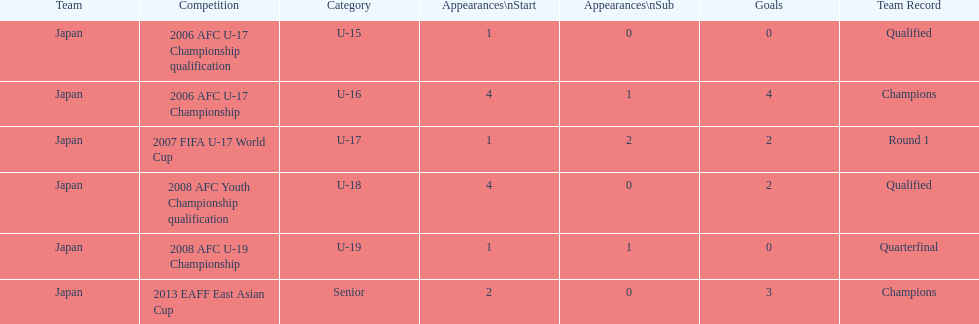What competition did japan compete in 2013? 2013 EAFF East Asian Cup. 